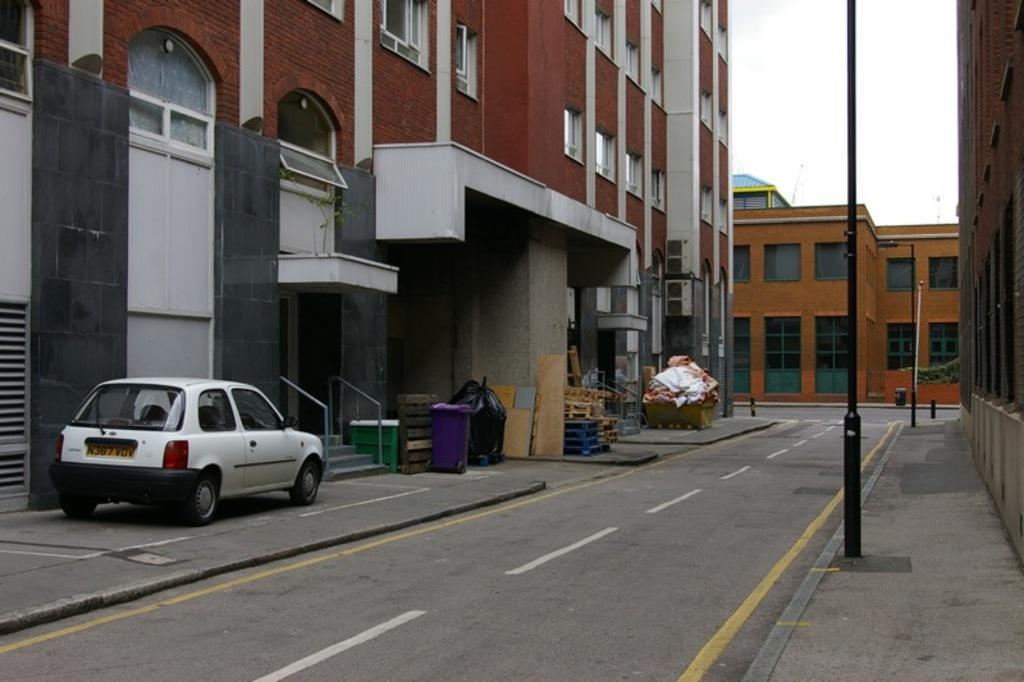Please provide a concise description of this image. In this picture there is a white color car which is parked near to the stairs. Beside that I can see the doors. On the right and left side I can see the buildings. In front of the door I can see the dustbins and plastic covers. In the top right I can see the sky and clouds. Beside the road I can see some wooden boxes and street lights. 